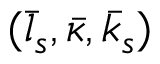Convert formula to latex. <formula><loc_0><loc_0><loc_500><loc_500>( \bar { l } _ { s } , \bar { \kappa } , \bar { k } _ { s } )</formula> 